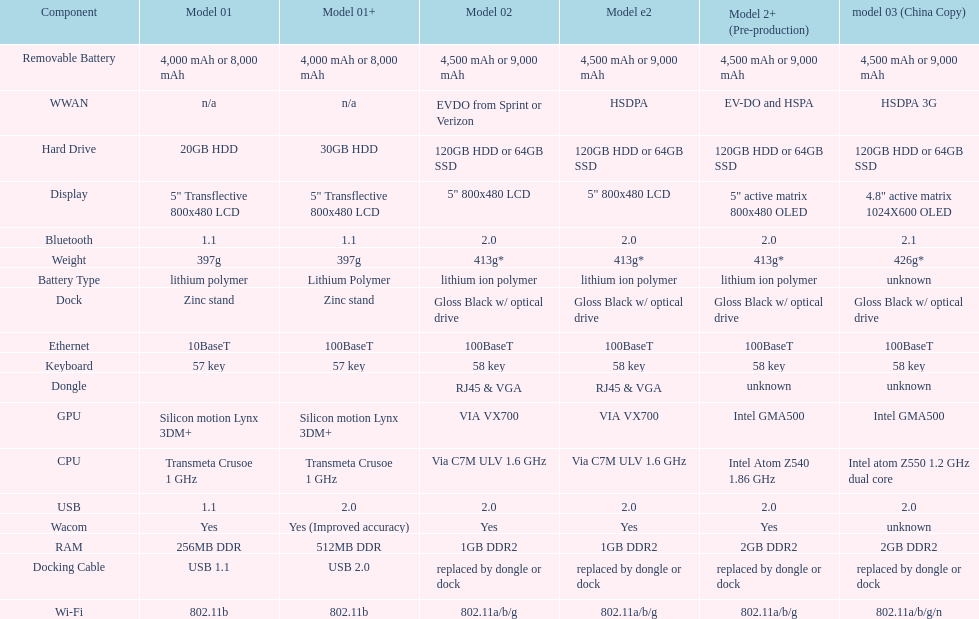What is the component before usb? Display. 